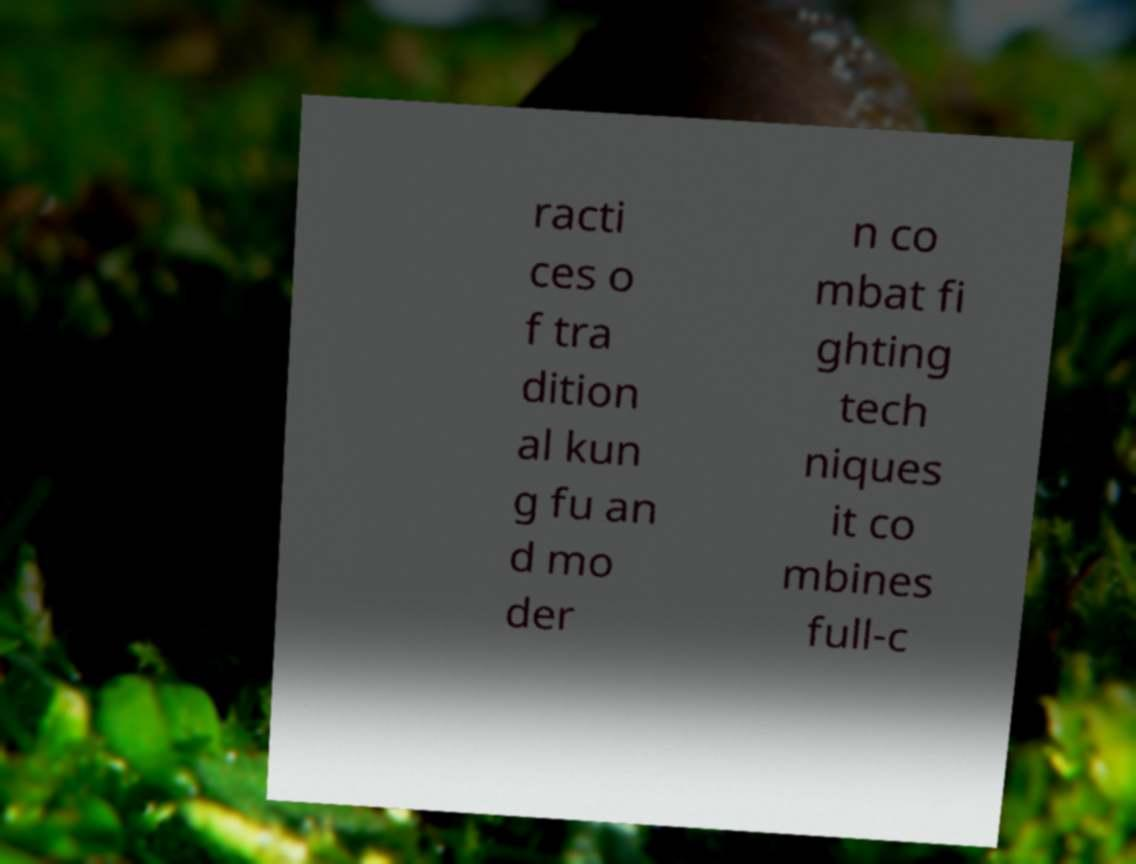For documentation purposes, I need the text within this image transcribed. Could you provide that? racti ces o f tra dition al kun g fu an d mo der n co mbat fi ghting tech niques it co mbines full-c 